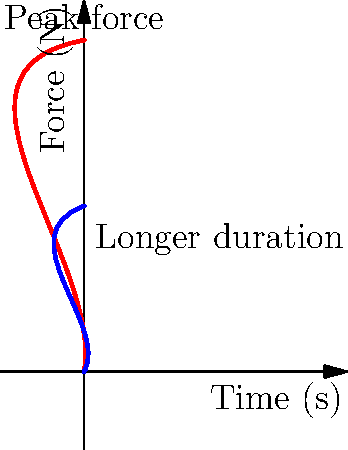Based on the force-time curves shown for high-impact and low-impact HIIT exercises, which biomechanical factor is most likely to contribute to increased caloric expenditure in high-impact exercises, and how might this affect your meal planning strategy for HIIT performance? To answer this question, let's analyze the force-time curves step-by-step:

1. High-impact curve (red):
   - Reaches a higher peak force
   - Steeper initial slope
   - Shorter duration of force application

2. Low-impact curve (blue):
   - Lower peak force
   - Gentler slope
   - Longer duration of force application

3. Biomechanical differences:
   - High-impact exercises involve greater ground reaction forces
   - This leads to increased muscle activation and energy expenditure

4. Caloric expenditure:
   - Higher peak forces in high-impact exercises require more energy
   - This results in greater caloric burn per unit of time

5. Effect on meal planning:
   - High-impact HIIT will require more energy substrates
   - Increased need for readily available carbohydrates
   - Higher protein requirements for muscle repair

6. Nutritional strategy:
   - Increase carbohydrate intake before and after high-impact HIIT sessions
   - Ensure adequate protein for muscle recovery
   - Consider timing of meals to optimize energy availability and recovery

The primary biomechanical factor contributing to increased caloric expenditure in high-impact exercises is the higher peak force, which requires more energy to generate and absorb. This would necessitate a meal plan with increased carbohydrate and protein content to support the higher energy demands and muscle recovery needs of high-impact HIIT.
Answer: Higher peak force, requiring increased carbohydrate and protein intake for energy and recovery. 